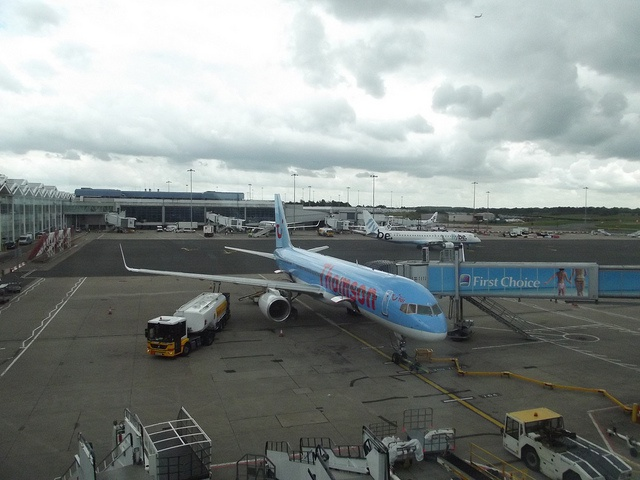Describe the objects in this image and their specific colors. I can see airplane in white, gray, black, and darkgray tones, truck in white, black, gray, and olive tones, truck in white, black, darkgray, gray, and olive tones, airplane in white, darkgray, gray, and black tones, and airplane in white, gray, darkgray, and black tones in this image. 